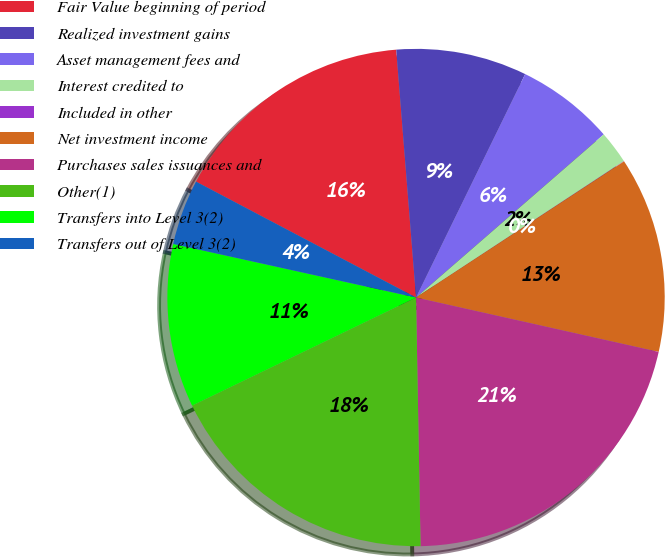Convert chart to OTSL. <chart><loc_0><loc_0><loc_500><loc_500><pie_chart><fcel>Fair Value beginning of period<fcel>Realized investment gains<fcel>Asset management fees and<fcel>Interest credited to<fcel>Included in other<fcel>Net investment income<fcel>Purchases sales issuances and<fcel>Other(1)<fcel>Transfers into Level 3(2)<fcel>Transfers out of Level 3(2)<nl><fcel>16.01%<fcel>8.5%<fcel>6.38%<fcel>2.14%<fcel>0.02%<fcel>12.73%<fcel>21.2%<fcel>18.13%<fcel>10.61%<fcel>4.26%<nl></chart> 